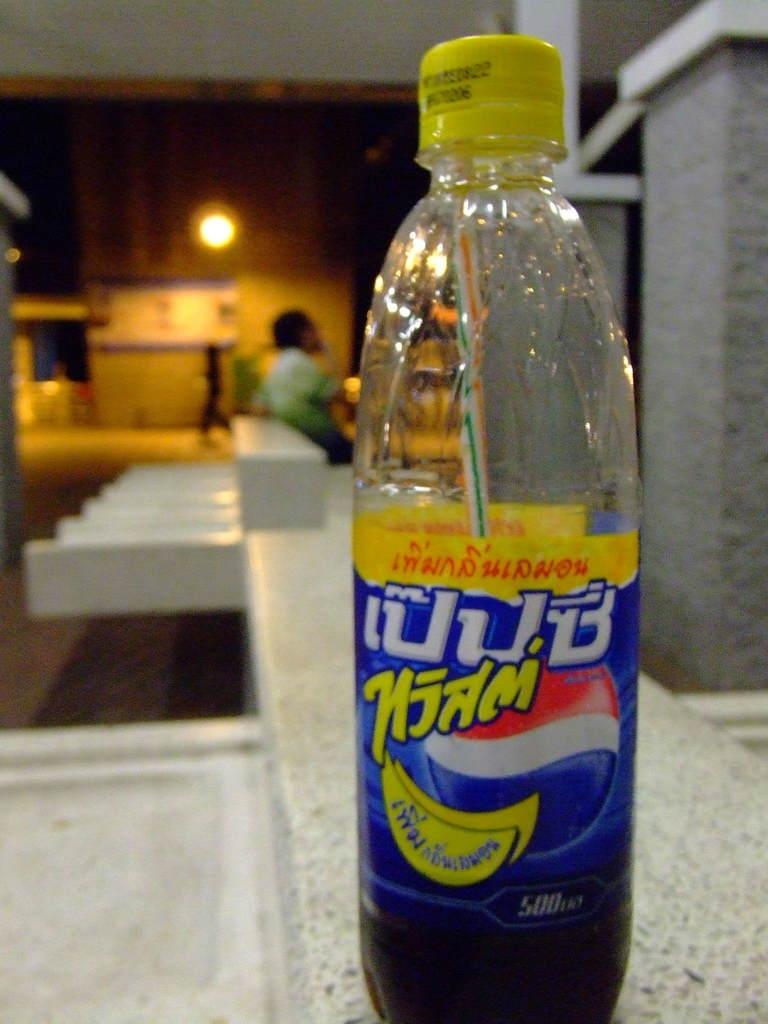What is the main object visible in the image? There is a cool drink bottle in the image. Can you describe the person in the image? There is a person on the top left of the image. What type of test is being conducted by the boys in the image? There are no boys present in the image, and therefore no test is being conducted. 